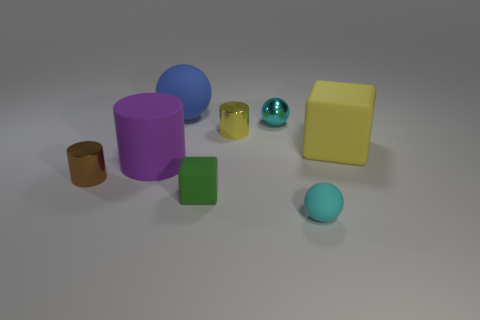Add 2 tiny metallic cylinders. How many objects exist? 10 Subtract all balls. How many objects are left? 5 Add 4 cyan metal objects. How many cyan metal objects exist? 5 Subtract 1 yellow cylinders. How many objects are left? 7 Subtract all cyan spheres. Subtract all small yellow things. How many objects are left? 5 Add 8 shiny cylinders. How many shiny cylinders are left? 10 